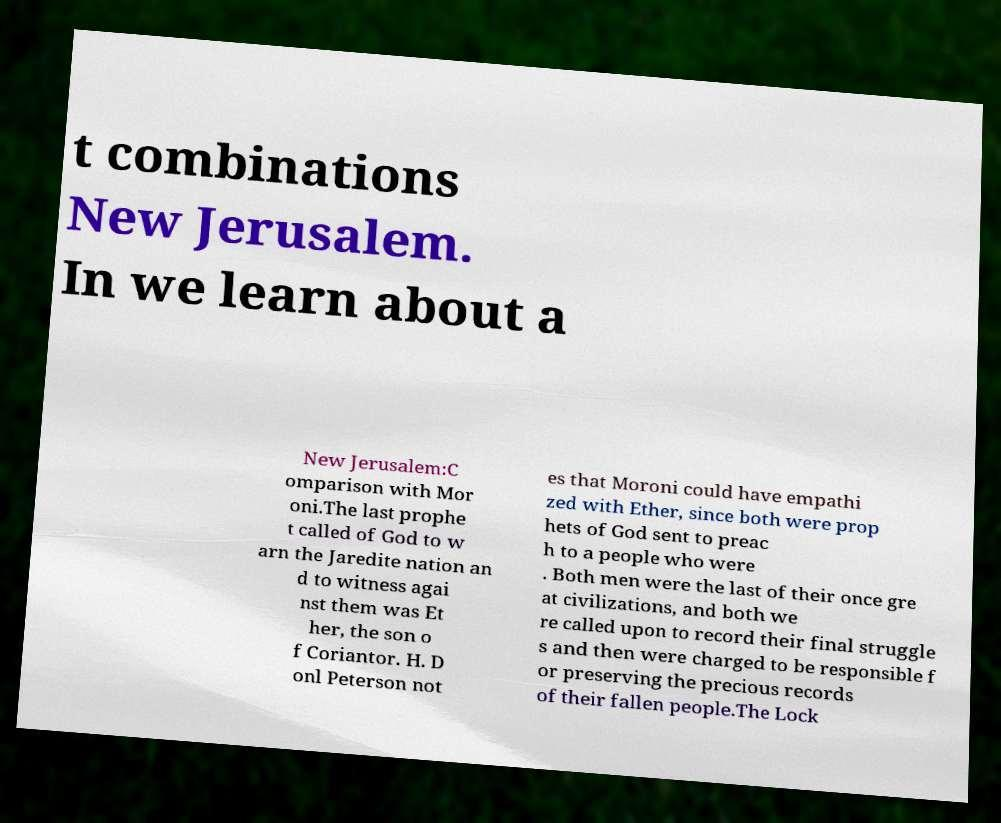Please read and relay the text visible in this image. What does it say? t combinations New Jerusalem. In we learn about a New Jerusalem:C omparison with Mor oni.The last prophe t called of God to w arn the Jaredite nation an d to witness agai nst them was Et her, the son o f Coriantor. H. D onl Peterson not es that Moroni could have empathi zed with Ether, since both were prop hets of God sent to preac h to a people who were . Both men were the last of their once gre at civilizations, and both we re called upon to record their final struggle s and then were charged to be responsible f or preserving the precious records of their fallen people.The Lock 